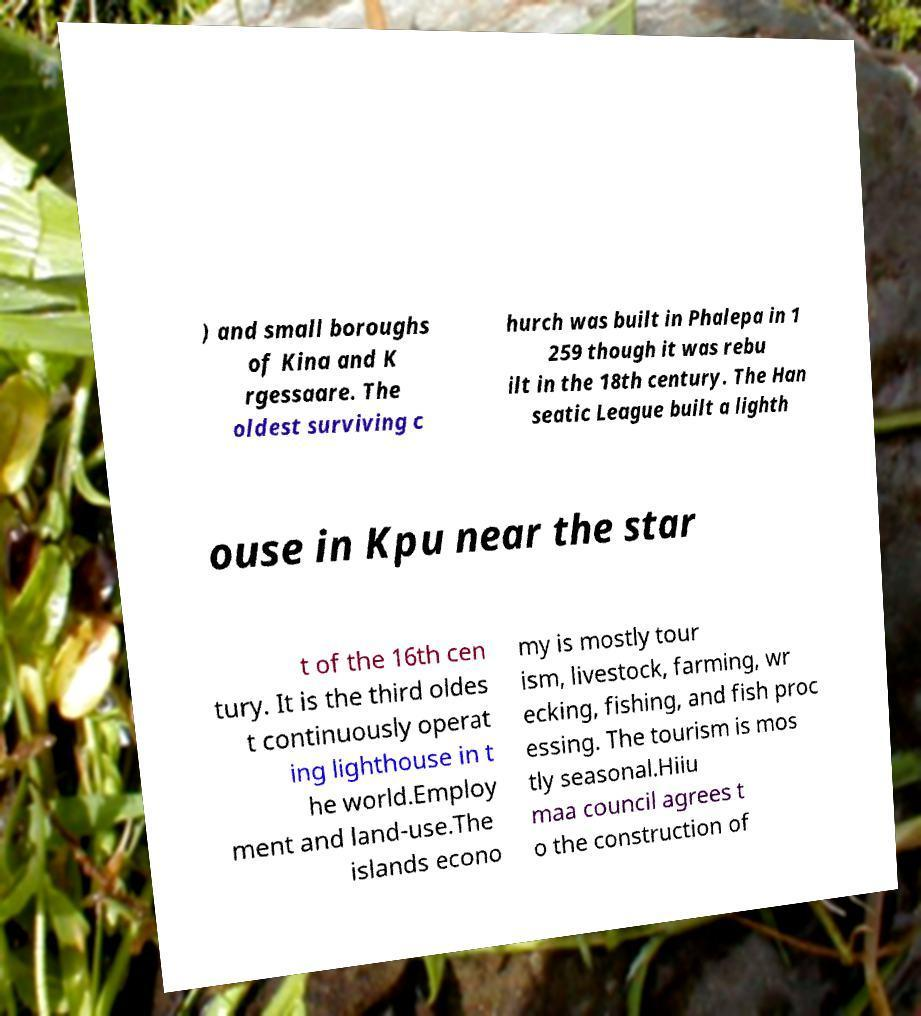Could you assist in decoding the text presented in this image and type it out clearly? ) and small boroughs of Kina and K rgessaare. The oldest surviving c hurch was built in Phalepa in 1 259 though it was rebu ilt in the 18th century. The Han seatic League built a lighth ouse in Kpu near the star t of the 16th cen tury. It is the third oldes t continuously operat ing lighthouse in t he world.Employ ment and land-use.The islands econo my is mostly tour ism, livestock, farming, wr ecking, fishing, and fish proc essing. The tourism is mos tly seasonal.Hiiu maa council agrees t o the construction of 